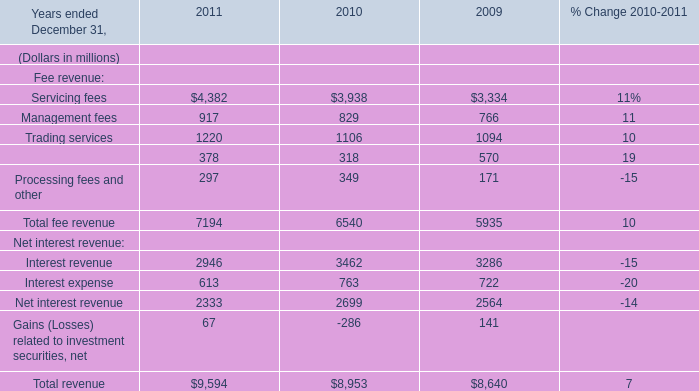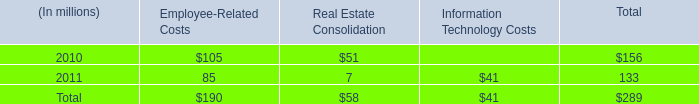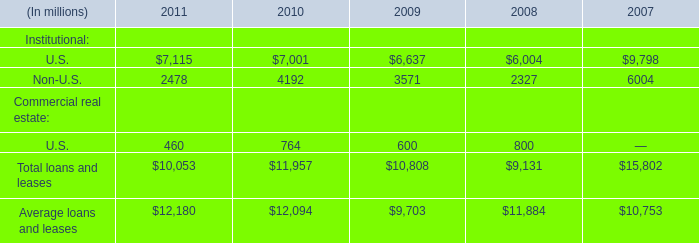What was the average value of service fees, management fees, trading services in 2010? (in million) 
Computations: (((3938 + 829) + 1106) / 3)
Answer: 1957.66667. 